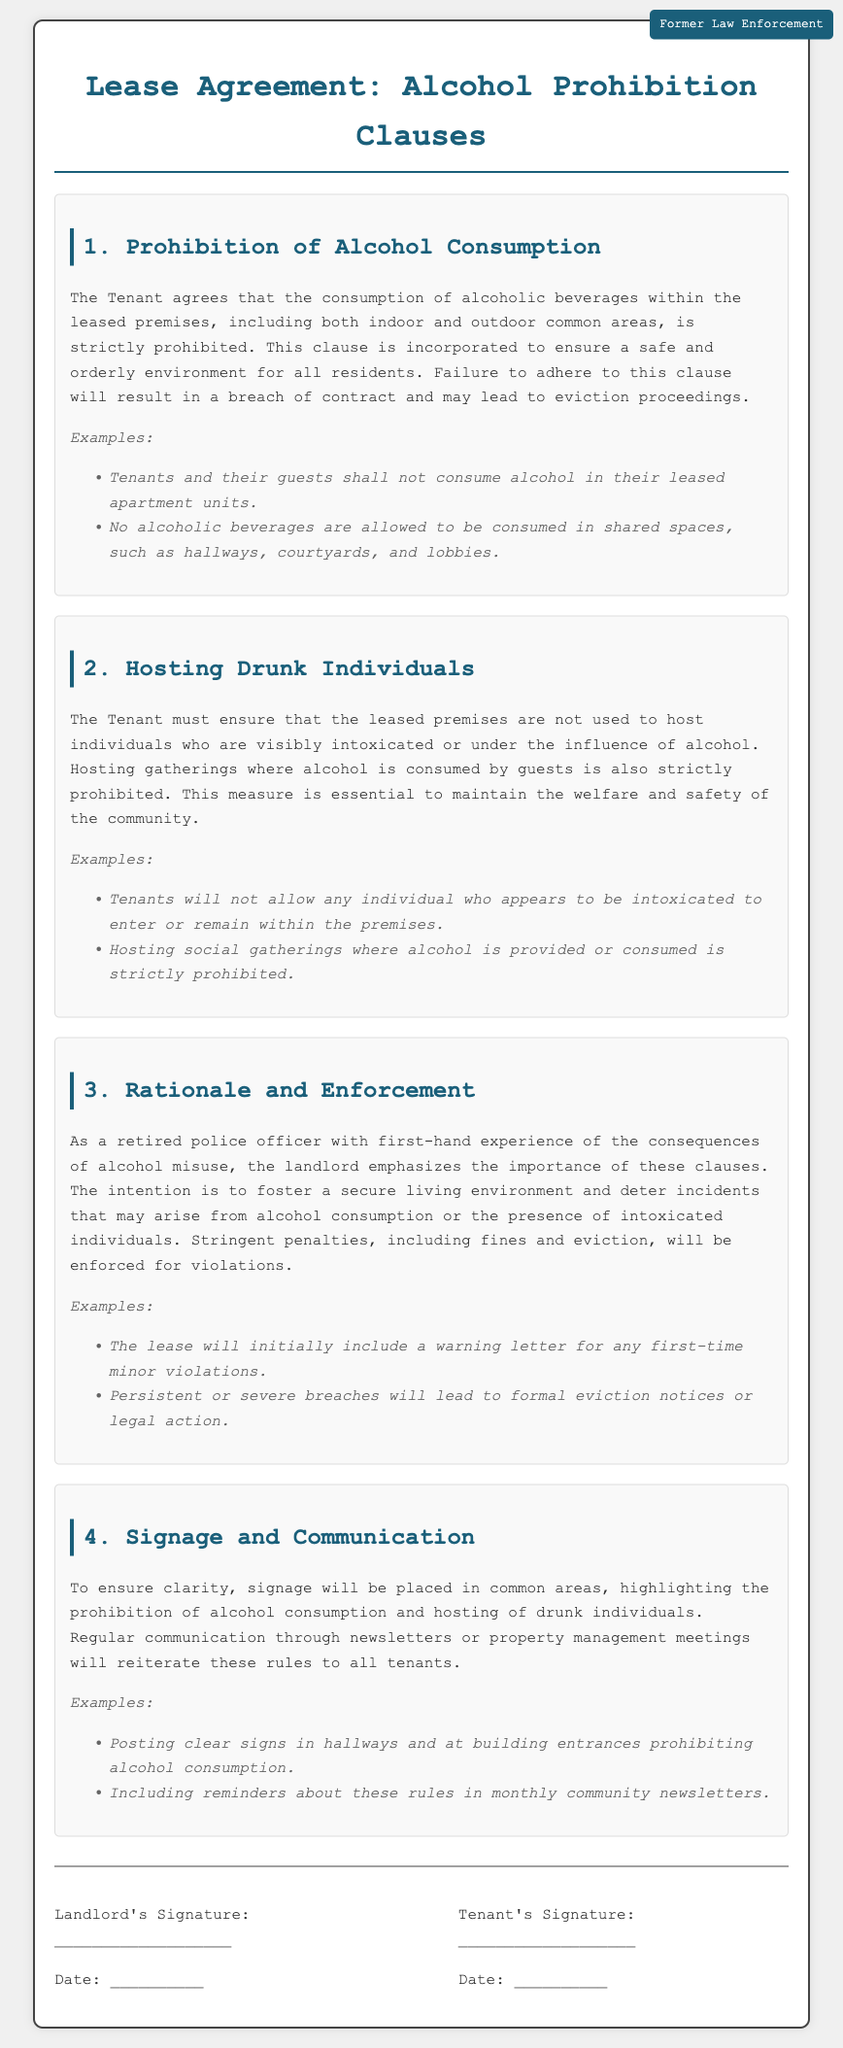What is the first clause in the lease agreement? The first clause outlined in the lease agreement is about the prohibition of alcohol consumption.
Answer: Prohibition of Alcohol Consumption What is strictly prohibited within the leased premises? The lease agreement clearly states that the consumption of alcoholic beverages is strictly prohibited within the leased premises.
Answer: Alcohol consumption What must tenants ensure regarding intoxicated individuals? Tenants must ensure that the leased premises are not used to host individuals who are visibly intoxicated or under the influence of alcohol.
Answer: Hosting intoxicated individuals What penalties may result from violating the alcohol prohibition clauses? The lease specifies that violations can lead to penalties, which include fines and eviction.
Answer: Fines and eviction How will the landlord communicate the alcohol prohibition rules? The landlord will use signage in common areas and regular communication through newsletters or property management meetings to remind tenants of the rules.
Answer: Signage and newsletters 